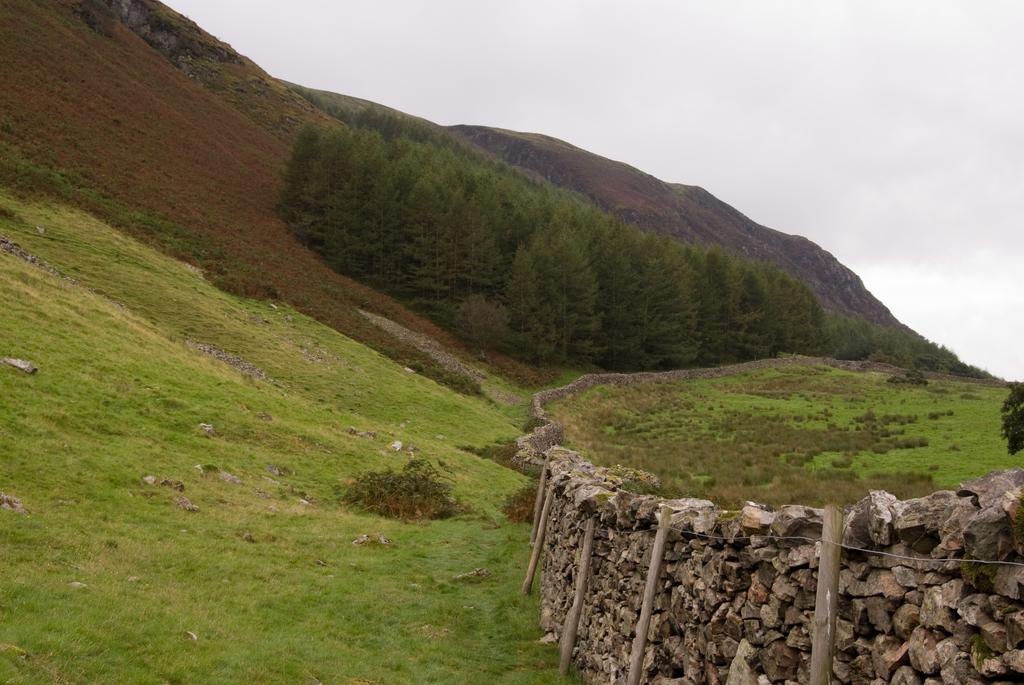What type of terrain is visible in the image? There is an open grass ground in the image. What natural elements can be seen in the image? There are trees in the image. How would you describe the sky in the image? The sky is visible and appears cloudy in the image. What man-made structures are present in the image? There are wooden poles and wire visible in the image. Can you see a kitten playing with feet in the image? There is no kitten or feet present in the image. What type of frog can be seen sitting on the wooden pole in the image? There is no frog present in the image; only trees, grass, wooden poles, and wire are visible. 